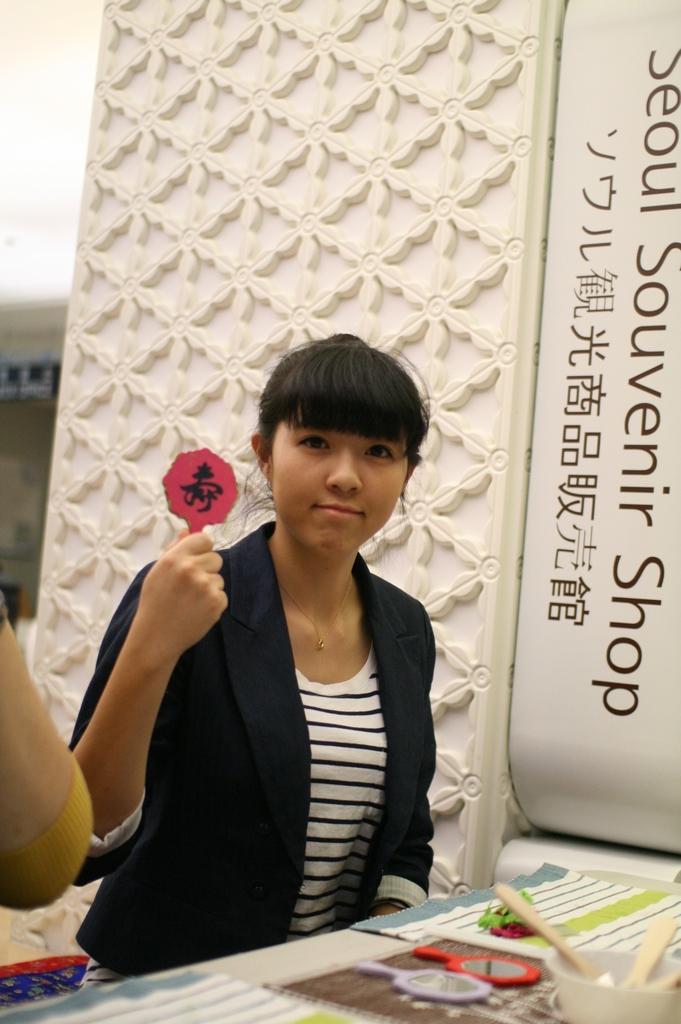Please provide a concise description of this image. In this picture we can see few people, in the middle of the image we can see a woman, she is holding a mirror, in front of her we can find a bowl, few mirrors and other things on the table, beside to her we can see a hoarding. 